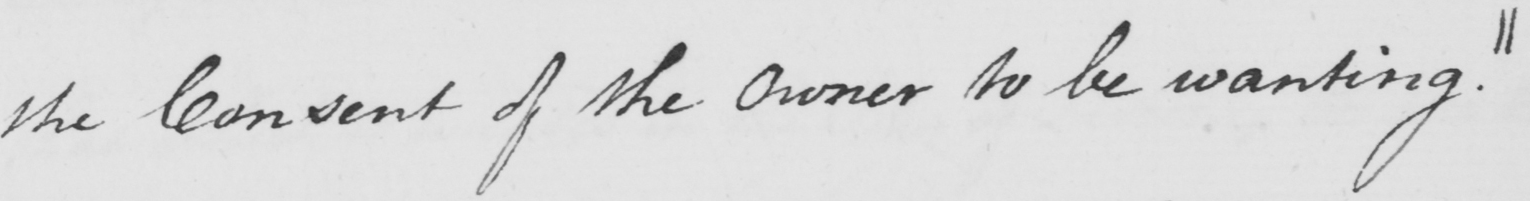Please transcribe the handwritten text in this image. the Consent of the owner to be wanting . || 